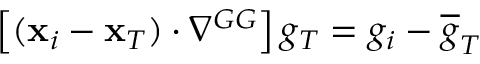<formula> <loc_0><loc_0><loc_500><loc_500>\left [ ( { x } _ { i } - { x } _ { T } ) \cdot \nabla ^ { G G } \right ] g _ { T } = { g } _ { i } - \overline { g } _ { T }</formula> 